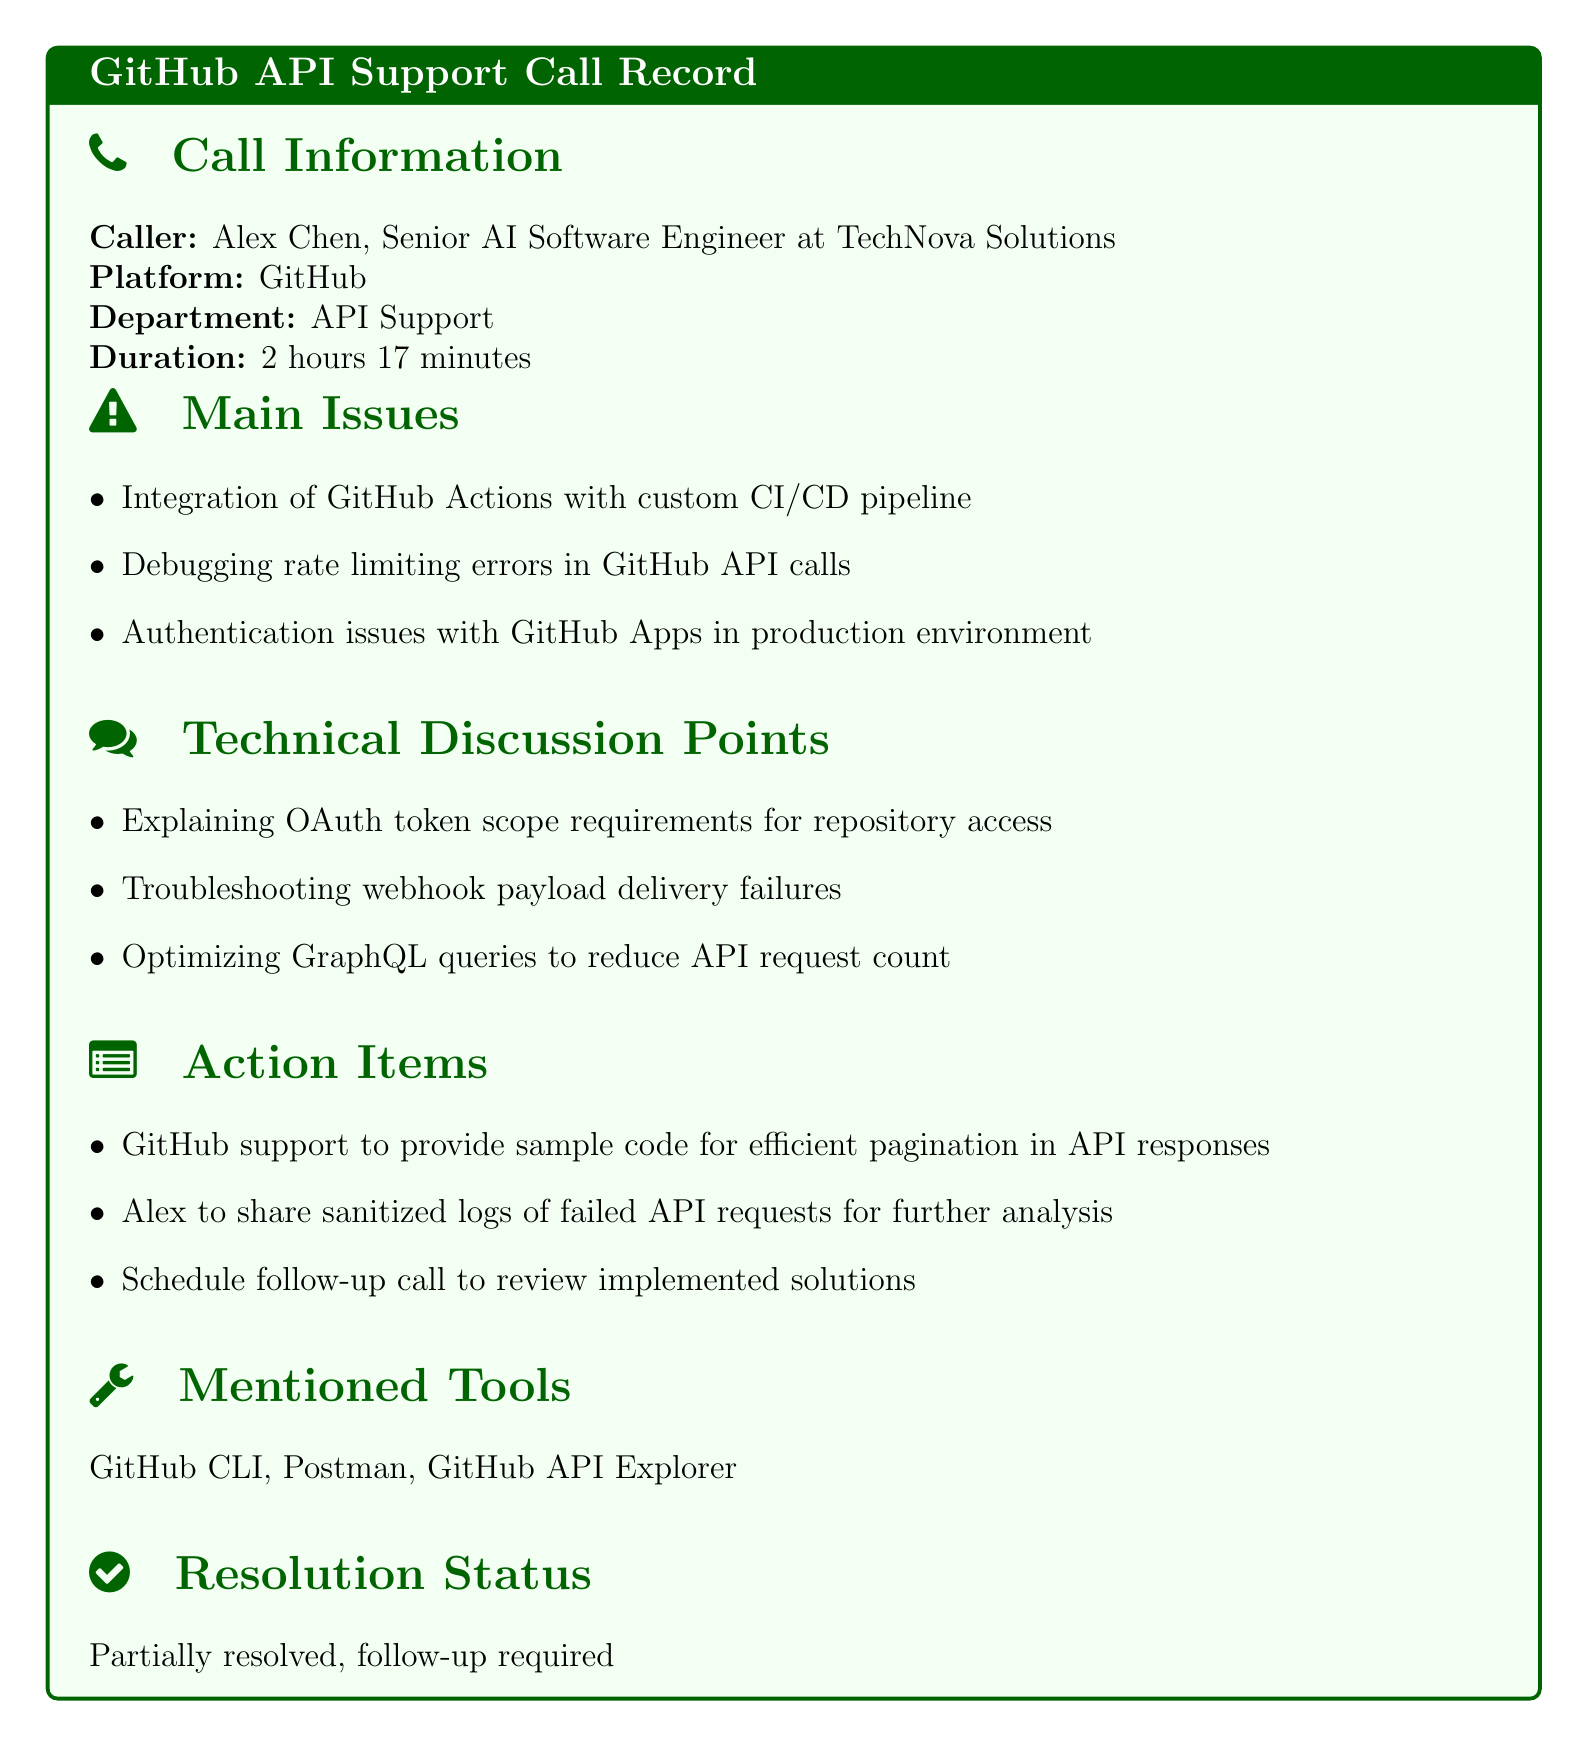What is the caller's name? The caller's name is specified in the call information section of the document.
Answer: Alex Chen What is the duration of the call? The duration is listed in the call information section.
Answer: 2 hours 17 minutes What are the main issues discussed? The main issues are outlined in the relevant section and include specific topics.
Answer: Integration of GitHub Actions with custom CI/CD pipeline What action item was assigned to Alex? The action items section details responsibilities assigned to Alex.
Answer: Share sanitized logs of failed API requests for further analysis What tools were mentioned during the call? The mentioned tools are listed explicitly under the relevant section in the document.
Answer: GitHub CLI, Postman, GitHub API Explorer What is the resolution status of the call? The resolution status is provided at the end of the document.
Answer: Partially resolved How many main issues were discussed? The number of main issues can be counted from the list in the document.
Answer: Three What API integration issue was raised? The specific API integration issue is noted in the main issues section.
Answer: Debugging rate limiting errors in GitHub API calls What follow-up was suggested? The follow-up actions are detailed in the action items section of the document.
Answer: Schedule follow-up call to review implemented solutions 